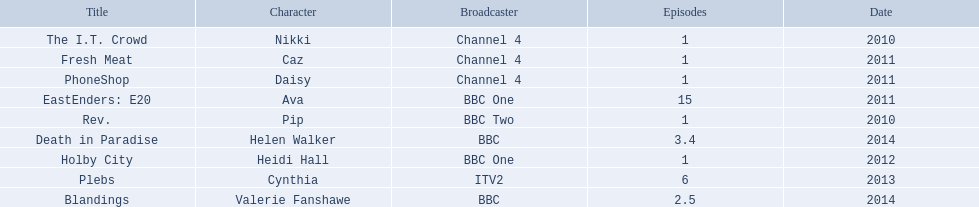Which characters were featured in more then one episode? Ava, Cynthia, Valerie Fanshawe, Helen Walker. Which of these were not in 2014? Ava, Cynthia. Which one of those was not on a bbc broadcaster? Cynthia. 